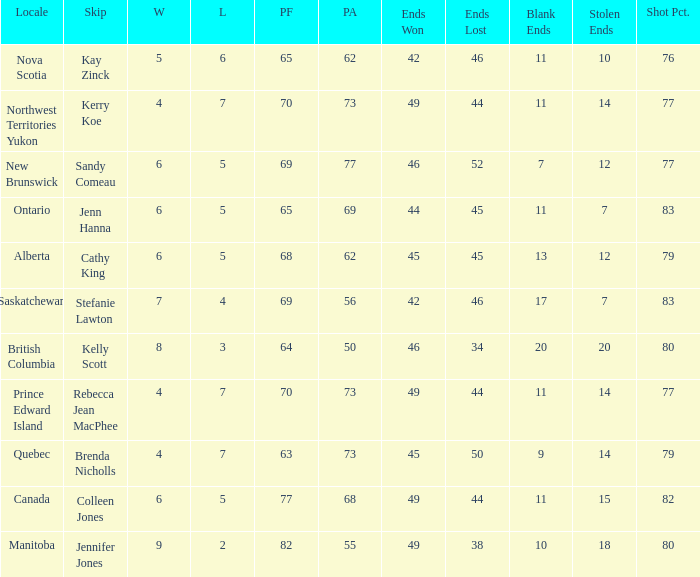What is the PA when the skip is Colleen Jones? 68.0. 